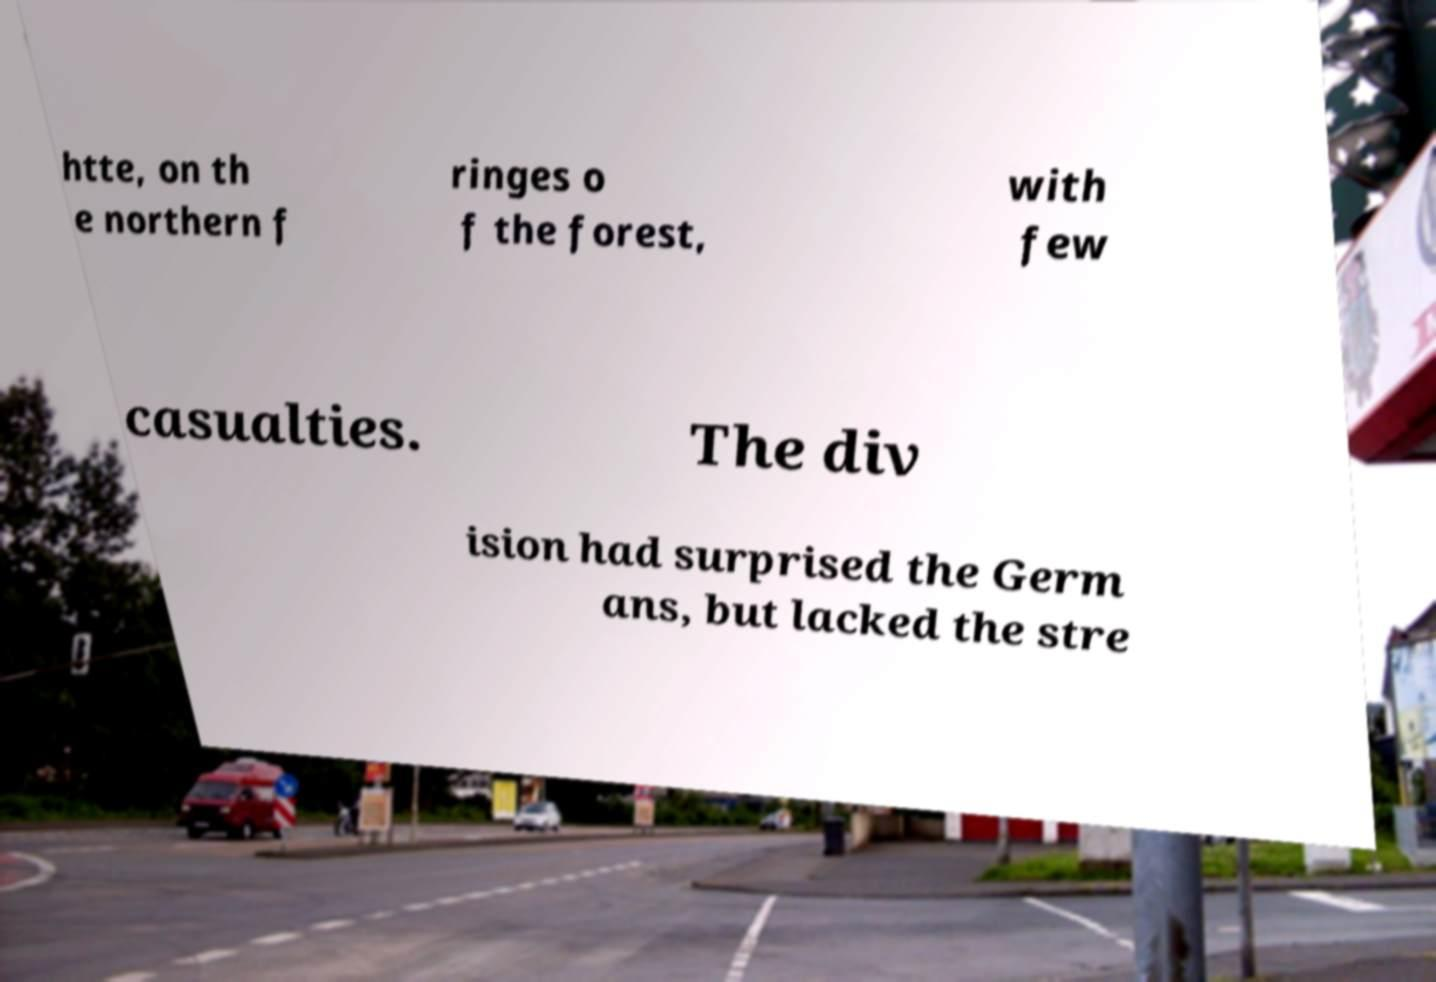Please read and relay the text visible in this image. What does it say? htte, on th e northern f ringes o f the forest, with few casualties. The div ision had surprised the Germ ans, but lacked the stre 